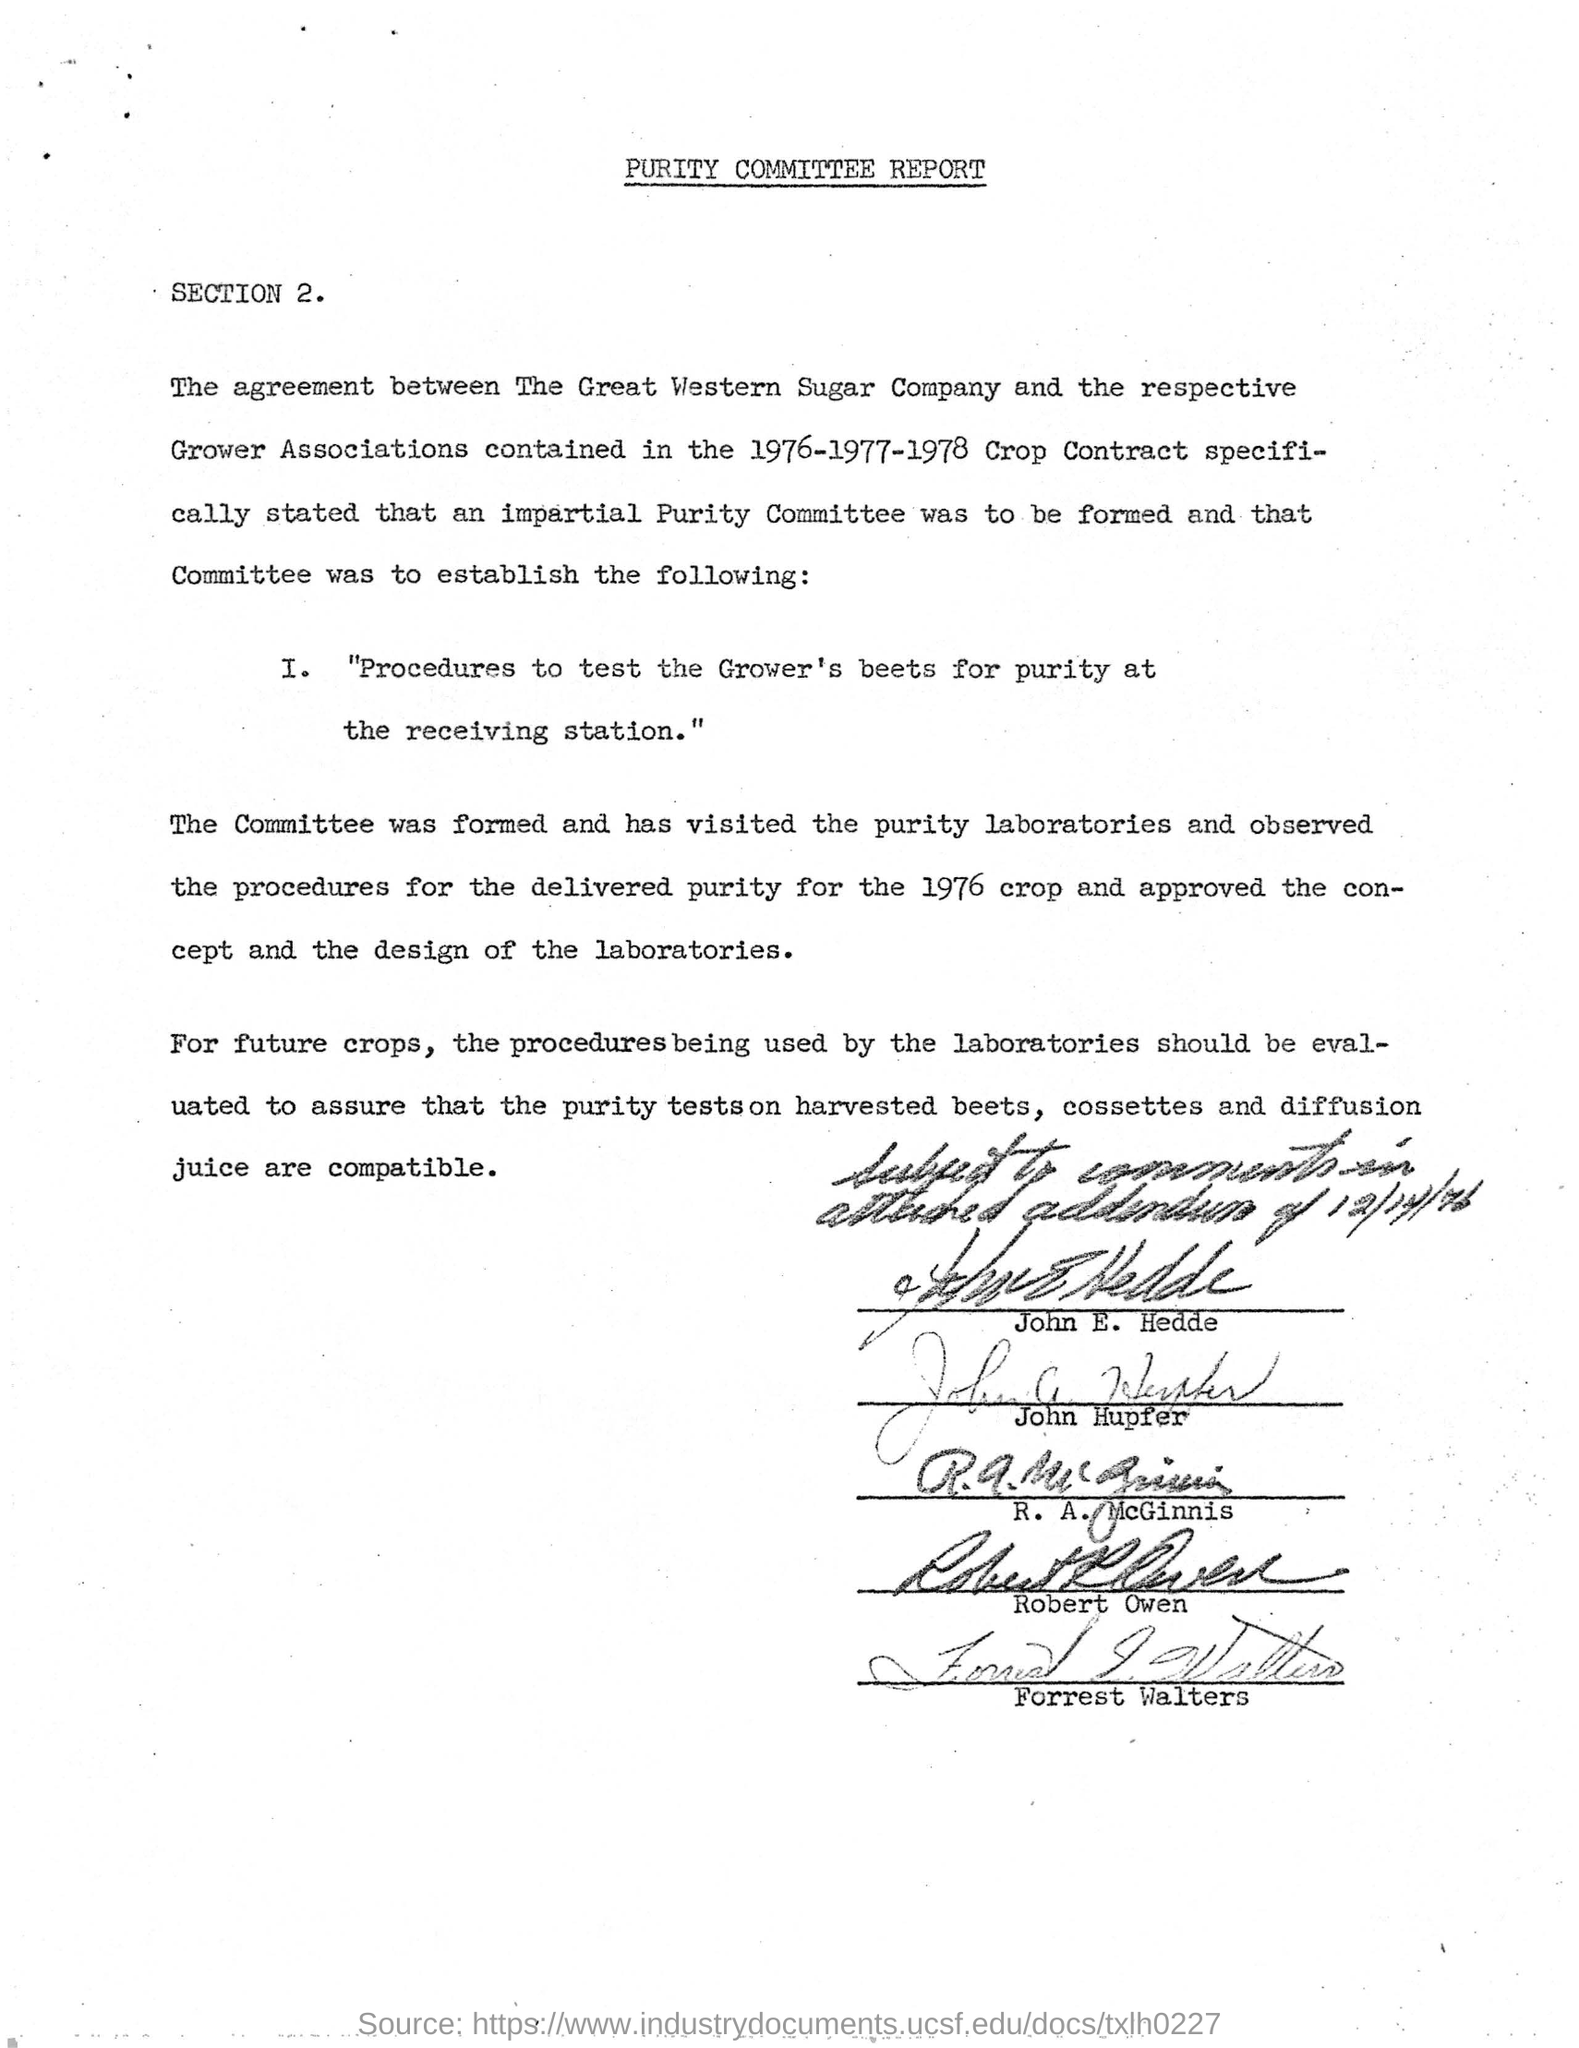Which crop contract contains the agreement between The Great Western Sugar company and the respective Grower association?
Your answer should be compact. 1976-1977-1978. 